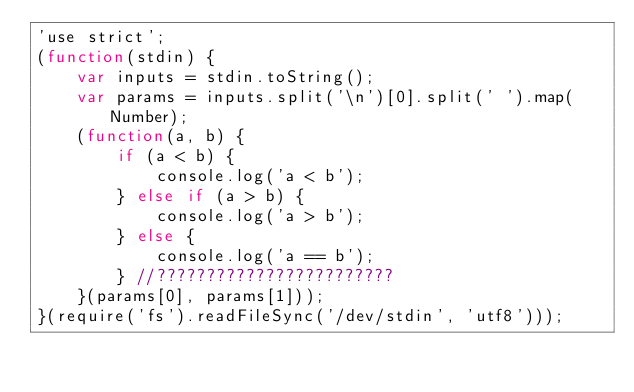<code> <loc_0><loc_0><loc_500><loc_500><_JavaScript_>'use strict';
(function(stdin) {
    var inputs = stdin.toString();
    var params = inputs.split('\n')[0].split(' ').map(Number);
    (function(a, b) {
        if (a < b) {
            console.log('a < b');
        } else if (a > b) {
            console.log('a > b');
        } else {
            console.log('a == b');
        } //????????????????????????
    }(params[0], params[1]));
}(require('fs').readFileSync('/dev/stdin', 'utf8')));</code> 